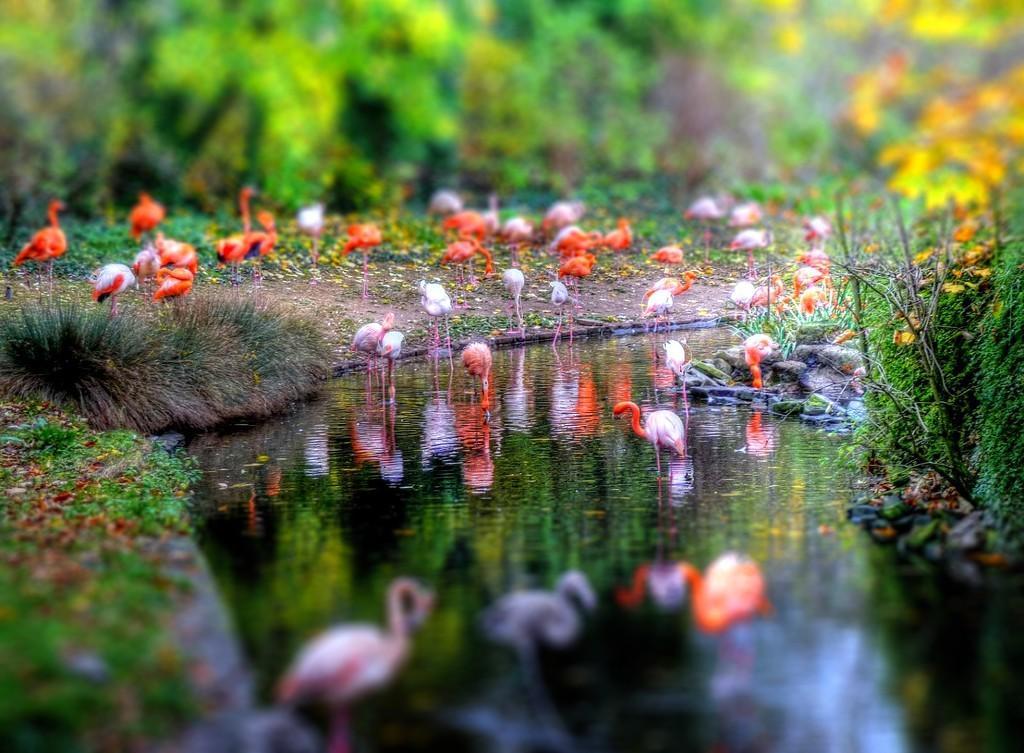In one or two sentences, can you explain what this image depicts? In this image at the bottom there is a pond, on the right side and left side there is grass and some plants. In the background there are some birds and trees and flowers. 